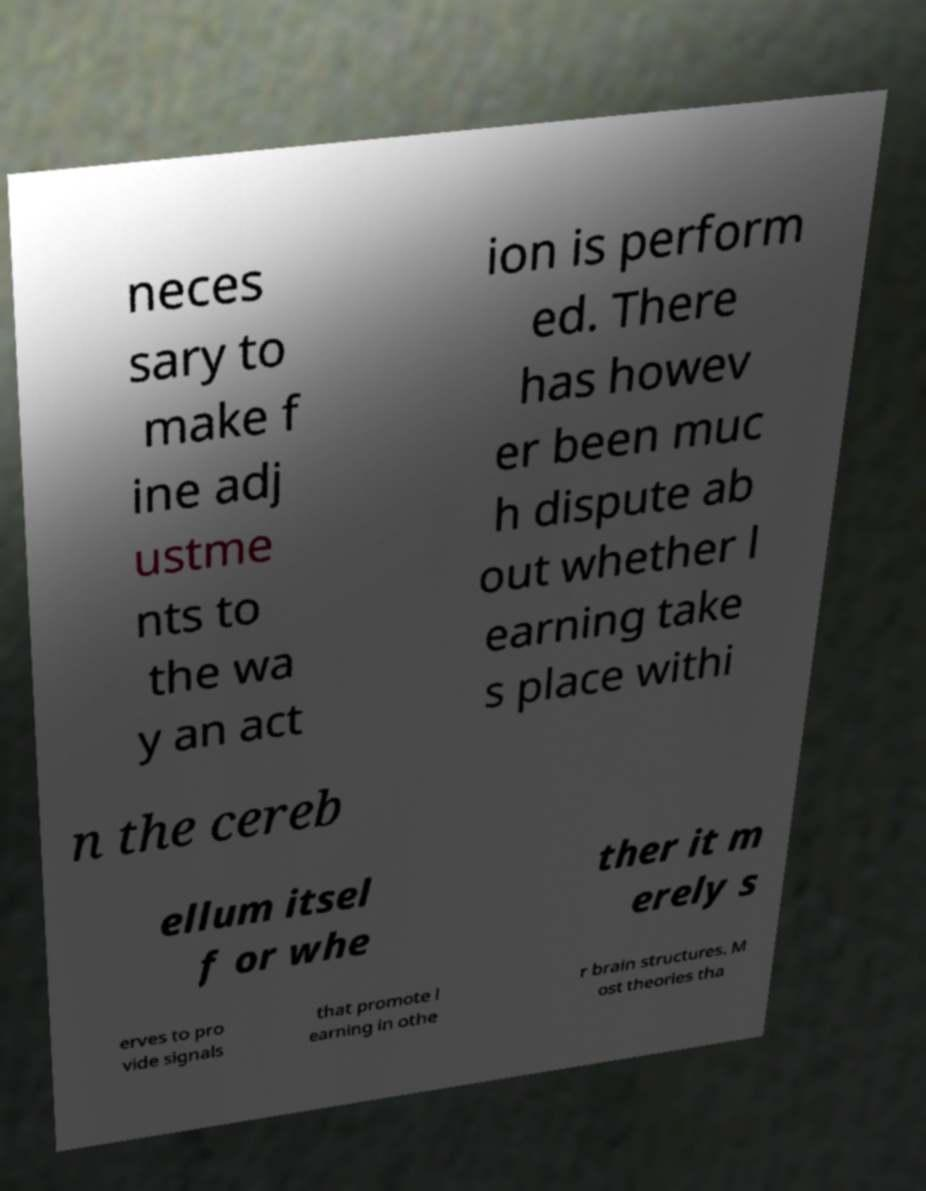There's text embedded in this image that I need extracted. Can you transcribe it verbatim? neces sary to make f ine adj ustme nts to the wa y an act ion is perform ed. There has howev er been muc h dispute ab out whether l earning take s place withi n the cereb ellum itsel f or whe ther it m erely s erves to pro vide signals that promote l earning in othe r brain structures. M ost theories tha 